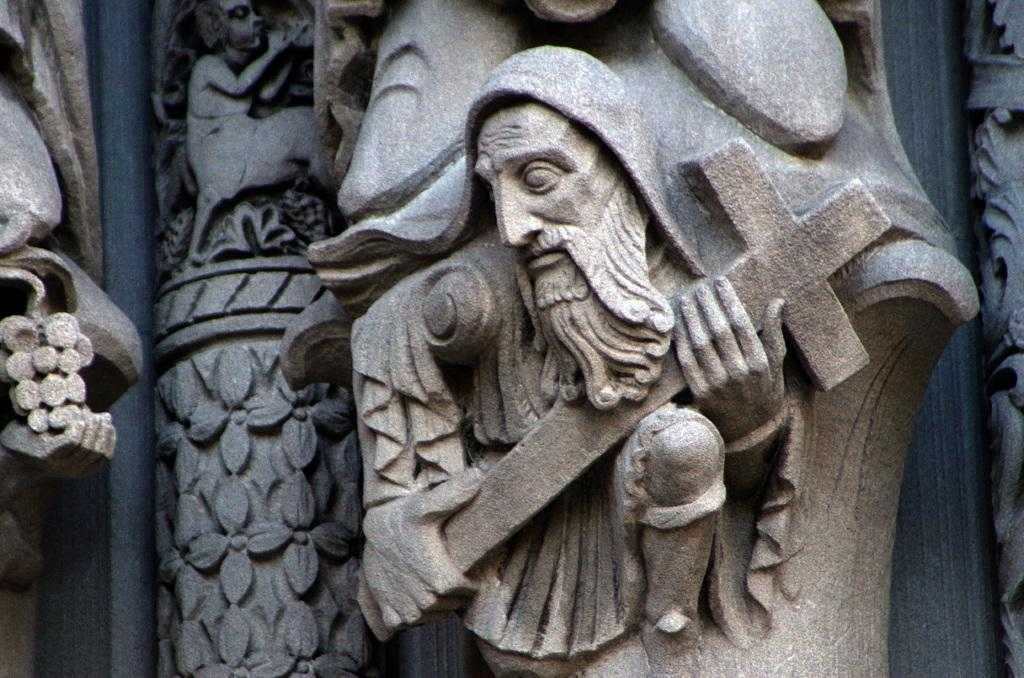What type of art is present in the image? There are sculptures in the image. What material were the sculptures made from? The sculptures are made of stone. How many children are holding the sculptures in the image? There are no children present in the image; it only features sculptures made of stone. 